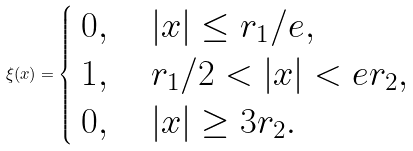<formula> <loc_0><loc_0><loc_500><loc_500>\xi ( x ) = \begin{cases} \begin{array} { l } 0 , \quad | x | \leq r _ { 1 } / e , \\ 1 , \quad r _ { 1 } / 2 < | x | < e r _ { 2 } , \\ 0 , \quad | x | \geq 3 r _ { 2 } . \end{array} \end{cases}</formula> 